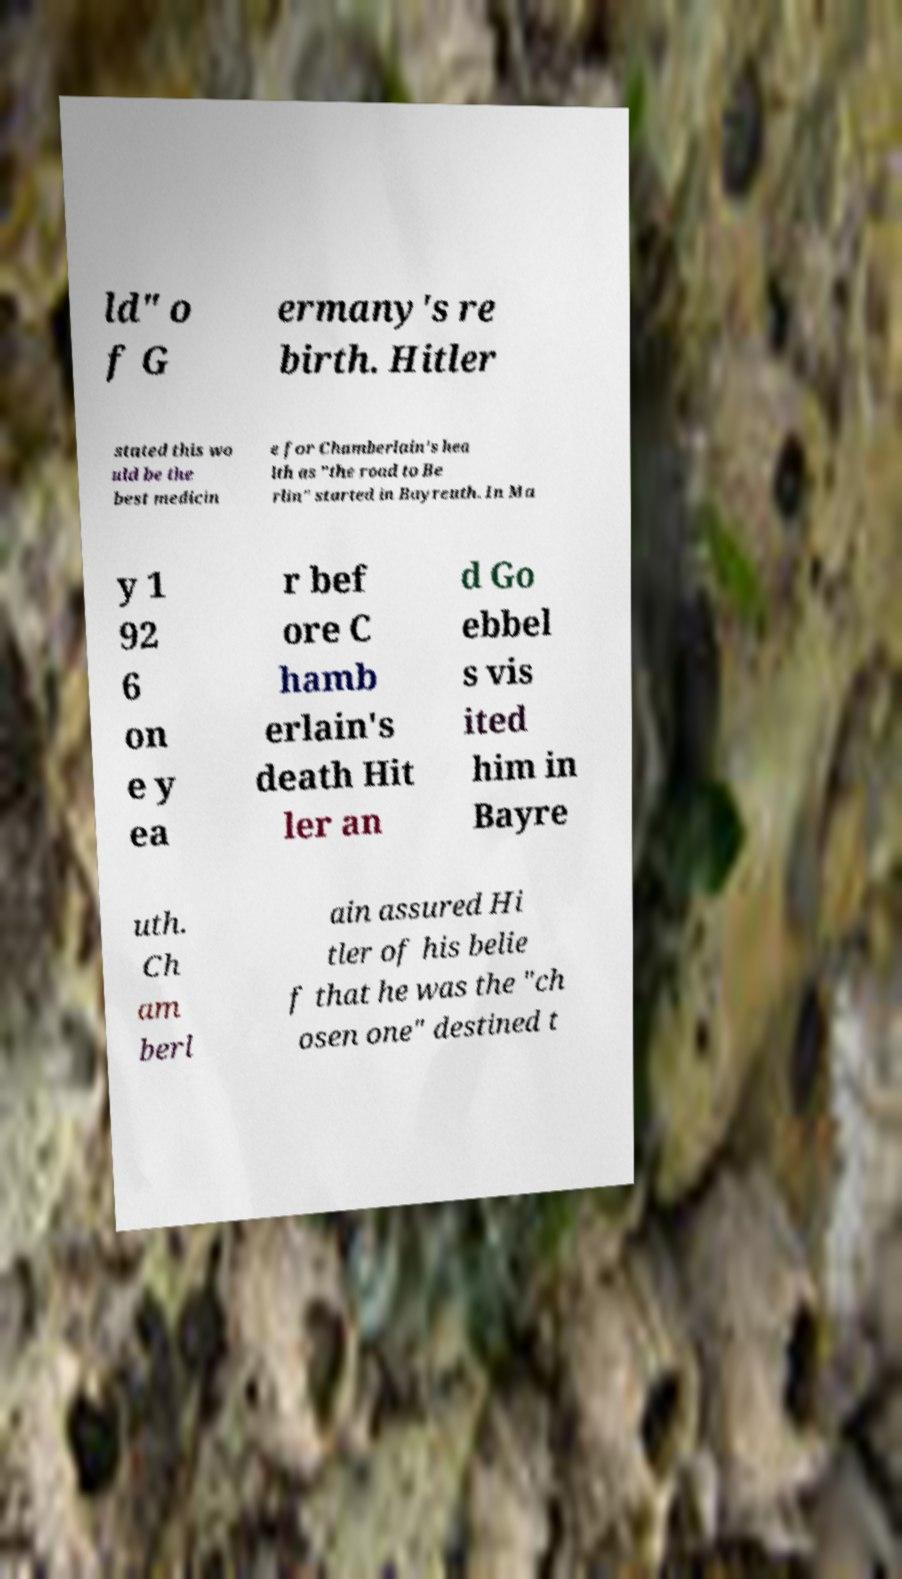Please read and relay the text visible in this image. What does it say? ld" o f G ermany's re birth. Hitler stated this wo uld be the best medicin e for Chamberlain's hea lth as "the road to Be rlin" started in Bayreuth. In Ma y 1 92 6 on e y ea r bef ore C hamb erlain's death Hit ler an d Go ebbel s vis ited him in Bayre uth. Ch am berl ain assured Hi tler of his belie f that he was the "ch osen one" destined t 